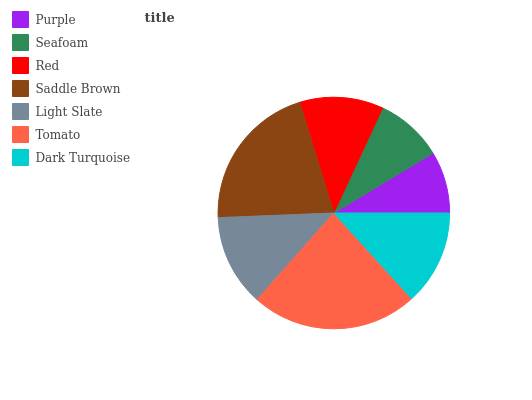Is Purple the minimum?
Answer yes or no. Yes. Is Tomato the maximum?
Answer yes or no. Yes. Is Seafoam the minimum?
Answer yes or no. No. Is Seafoam the maximum?
Answer yes or no. No. Is Seafoam greater than Purple?
Answer yes or no. Yes. Is Purple less than Seafoam?
Answer yes or no. Yes. Is Purple greater than Seafoam?
Answer yes or no. No. Is Seafoam less than Purple?
Answer yes or no. No. Is Light Slate the high median?
Answer yes or no. Yes. Is Light Slate the low median?
Answer yes or no. Yes. Is Purple the high median?
Answer yes or no. No. Is Seafoam the low median?
Answer yes or no. No. 